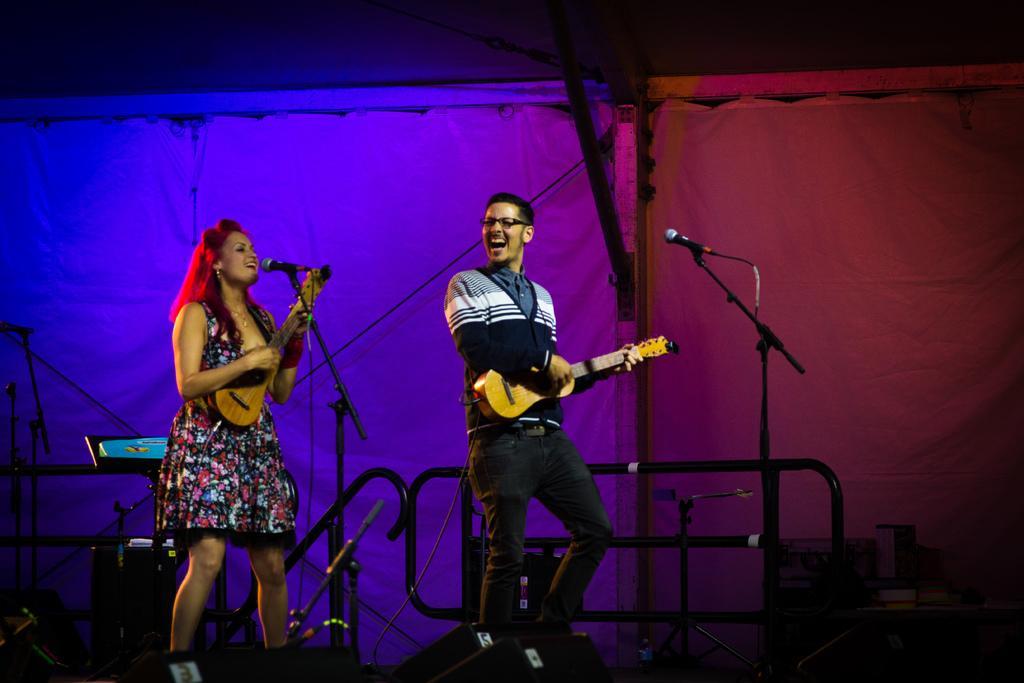Can you describe this image briefly? In this image on the right side there is one person who is standing and he is playing a guitar it seems that he is singing, in front of him there is one mike. On the left side there is one woman who is standing and she is playing a guitar and in front of her there is one mike it seems that she is singing on the background there is a cloth. 